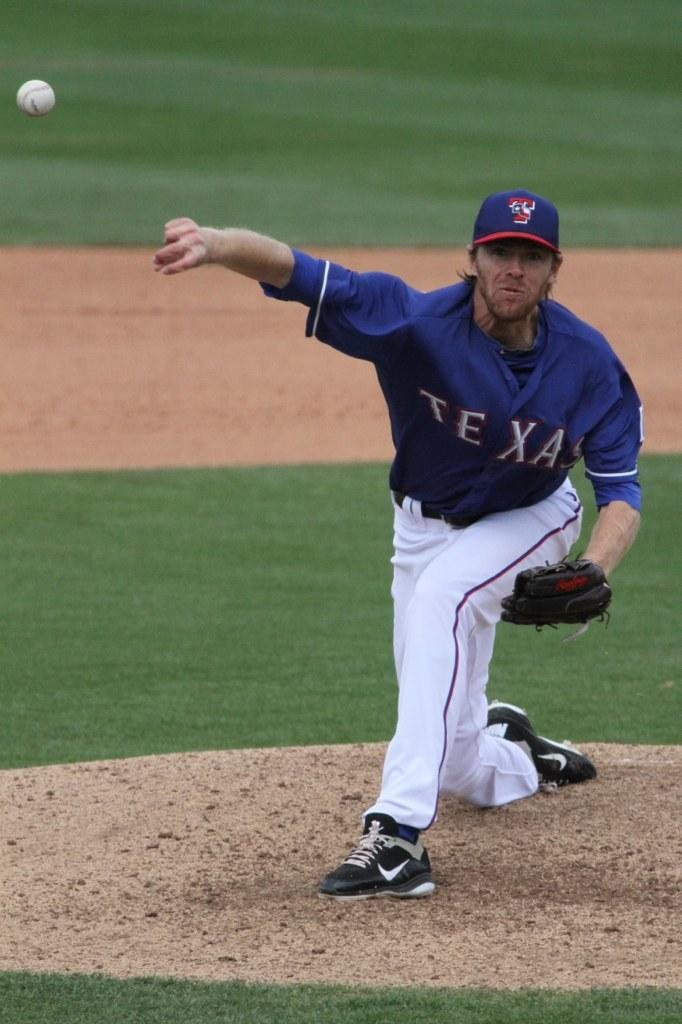<image>
Share a concise interpretation of the image provided. A pitcher for TEXAS throws the pitch across the mound 